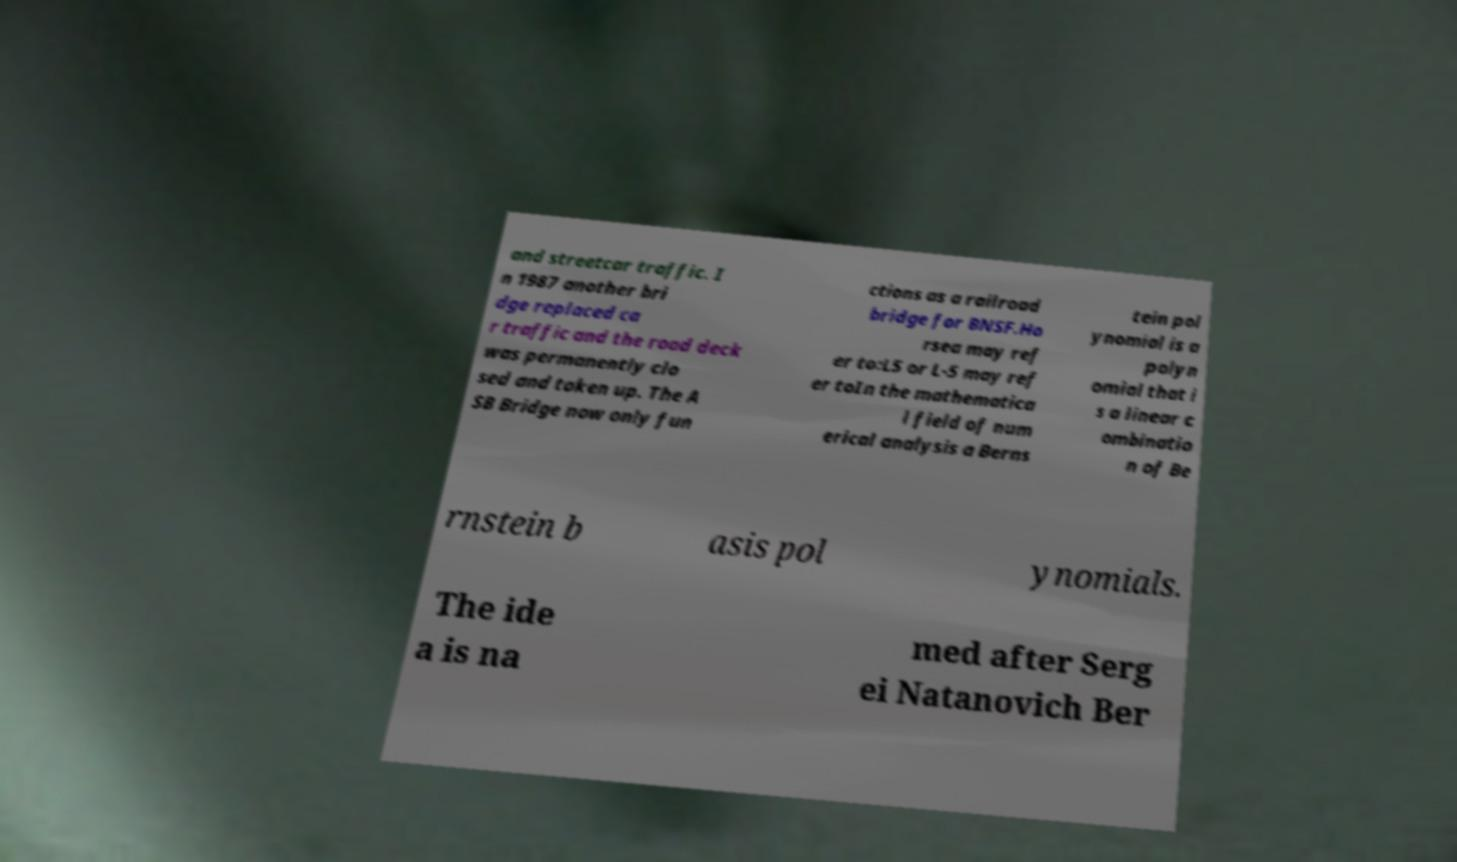Can you accurately transcribe the text from the provided image for me? and streetcar traffic. I n 1987 another bri dge replaced ca r traffic and the road deck was permanently clo sed and taken up. The A SB Bridge now only fun ctions as a railroad bridge for BNSF.Ho rsea may ref er to:L5 or L-5 may ref er toIn the mathematica l field of num erical analysis a Berns tein pol ynomial is a polyn omial that i s a linear c ombinatio n of Be rnstein b asis pol ynomials. The ide a is na med after Serg ei Natanovich Ber 